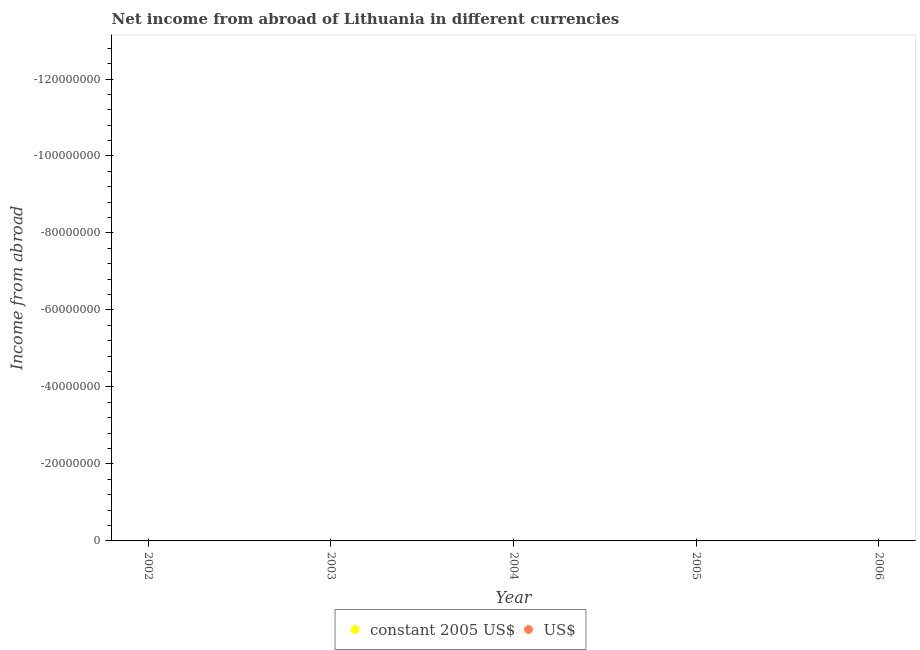How many different coloured dotlines are there?
Give a very brief answer. 0. What is the average income from abroad in constant 2005 us$ per year?
Give a very brief answer. 0. In how many years, is the income from abroad in constant 2005 us$ greater than the average income from abroad in constant 2005 us$ taken over all years?
Your response must be concise. 0. Is the income from abroad in constant 2005 us$ strictly less than the income from abroad in us$ over the years?
Offer a very short reply. No. How many years are there in the graph?
Your response must be concise. 5. What is the difference between two consecutive major ticks on the Y-axis?
Make the answer very short. 2.00e+07. Are the values on the major ticks of Y-axis written in scientific E-notation?
Make the answer very short. No. Does the graph contain any zero values?
Give a very brief answer. Yes. Where does the legend appear in the graph?
Offer a very short reply. Bottom center. How are the legend labels stacked?
Make the answer very short. Horizontal. What is the title of the graph?
Give a very brief answer. Net income from abroad of Lithuania in different currencies. Does "Taxes on exports" appear as one of the legend labels in the graph?
Ensure brevity in your answer.  No. What is the label or title of the Y-axis?
Provide a short and direct response. Income from abroad. What is the Income from abroad of US$ in 2003?
Keep it short and to the point. 0. What is the Income from abroad of constant 2005 US$ in 2005?
Offer a very short reply. 0. What is the Income from abroad in US$ in 2005?
Ensure brevity in your answer.  0. What is the Income from abroad of constant 2005 US$ in 2006?
Provide a succinct answer. 0. What is the Income from abroad in US$ in 2006?
Your answer should be compact. 0. 